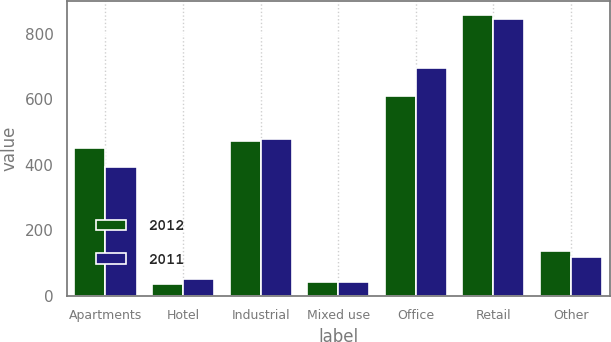Convert chart to OTSL. <chart><loc_0><loc_0><loc_500><loc_500><stacked_bar_chart><ecel><fcel>Apartments<fcel>Hotel<fcel>Industrial<fcel>Mixed use<fcel>Office<fcel>Retail<fcel>Other<nl><fcel>2012<fcel>450<fcel>36<fcel>474<fcel>42<fcel>610<fcel>858<fcel>136<nl><fcel>2011<fcel>392<fcel>51<fcel>480<fcel>42<fcel>694<fcel>845<fcel>120<nl></chart> 